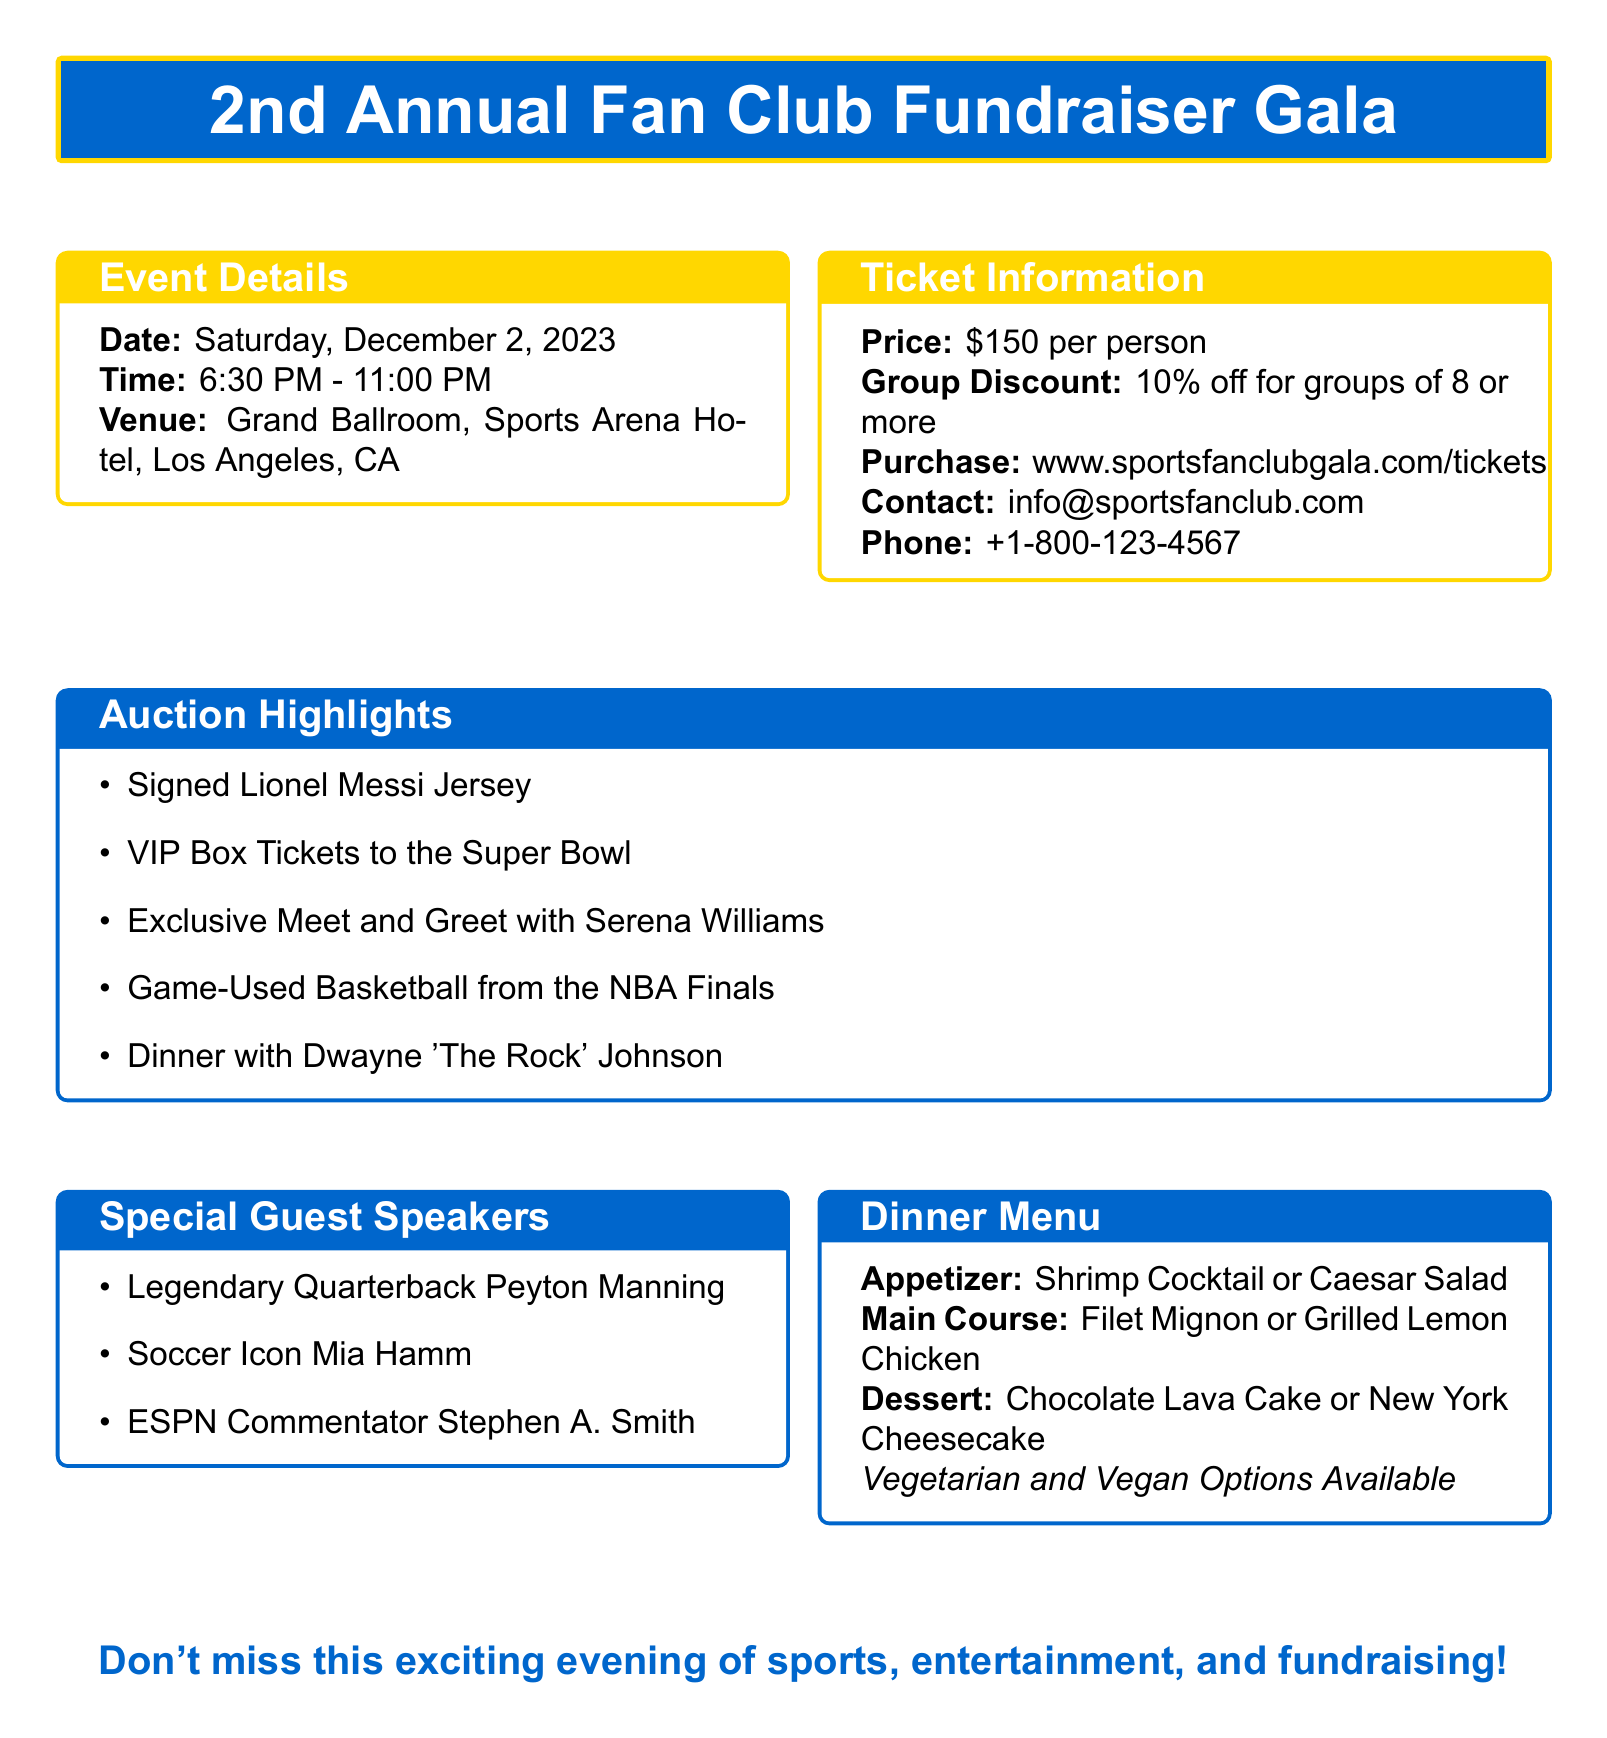What is the date of the gala? The date of the gala is mentioned in the event details section.
Answer: Saturday, December 2, 2023 What is the venue for the event? The venue is specified in the event details section of the document.
Answer: Grand Ballroom, Sports Arena Hotel, Los Angeles, CA How much does a ticket cost? The ticket price is provided in the ticket information box.
Answer: $150 per person What is the group discount percentage? The group discount is outlined in the ticket information section.
Answer: 10% off for groups of 8 or more Who is one of the special guest speakers? The special guest speakers are listed in their own section of the document.
Answer: Peyton Manning What is one auction highlight item? The auction highlights are enumerated in a separate box.
Answer: Signed Lionel Messi Jersey What are the main course options available? The main course options are mentioned in the dinner menu section.
Answer: Filet Mignon or Grilled Lemon Chicken Is there a vegetarian option available for dinner? The availability of vegetarian options is noted in the dinner menu.
Answer: Yes How can tickets be purchased? The ticket purchase method is described in the ticket information section.
Answer: www.sportsfanclubgala.com/tickets 